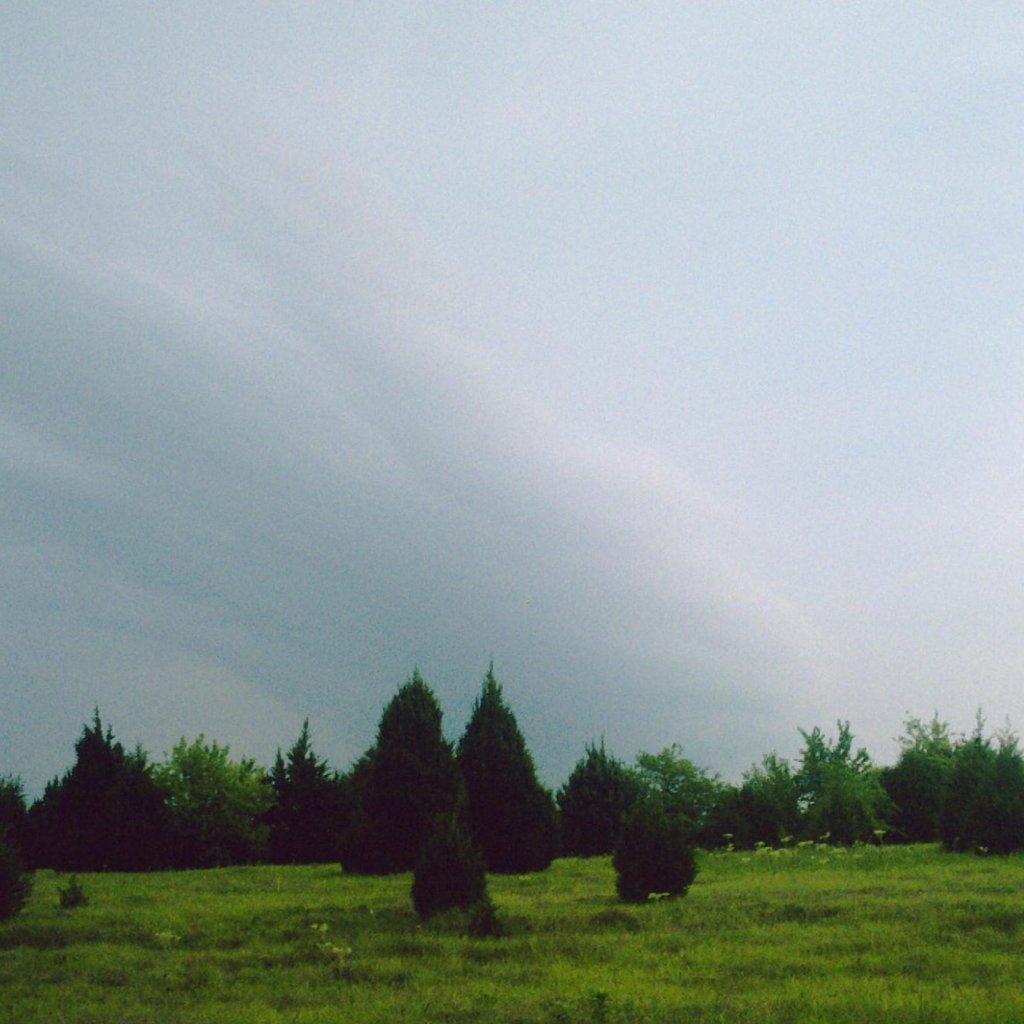How would you summarize this image in a sentence or two? In the foreground of this image, there is grass, trees and at the top, there is the sky ad the cloud. 